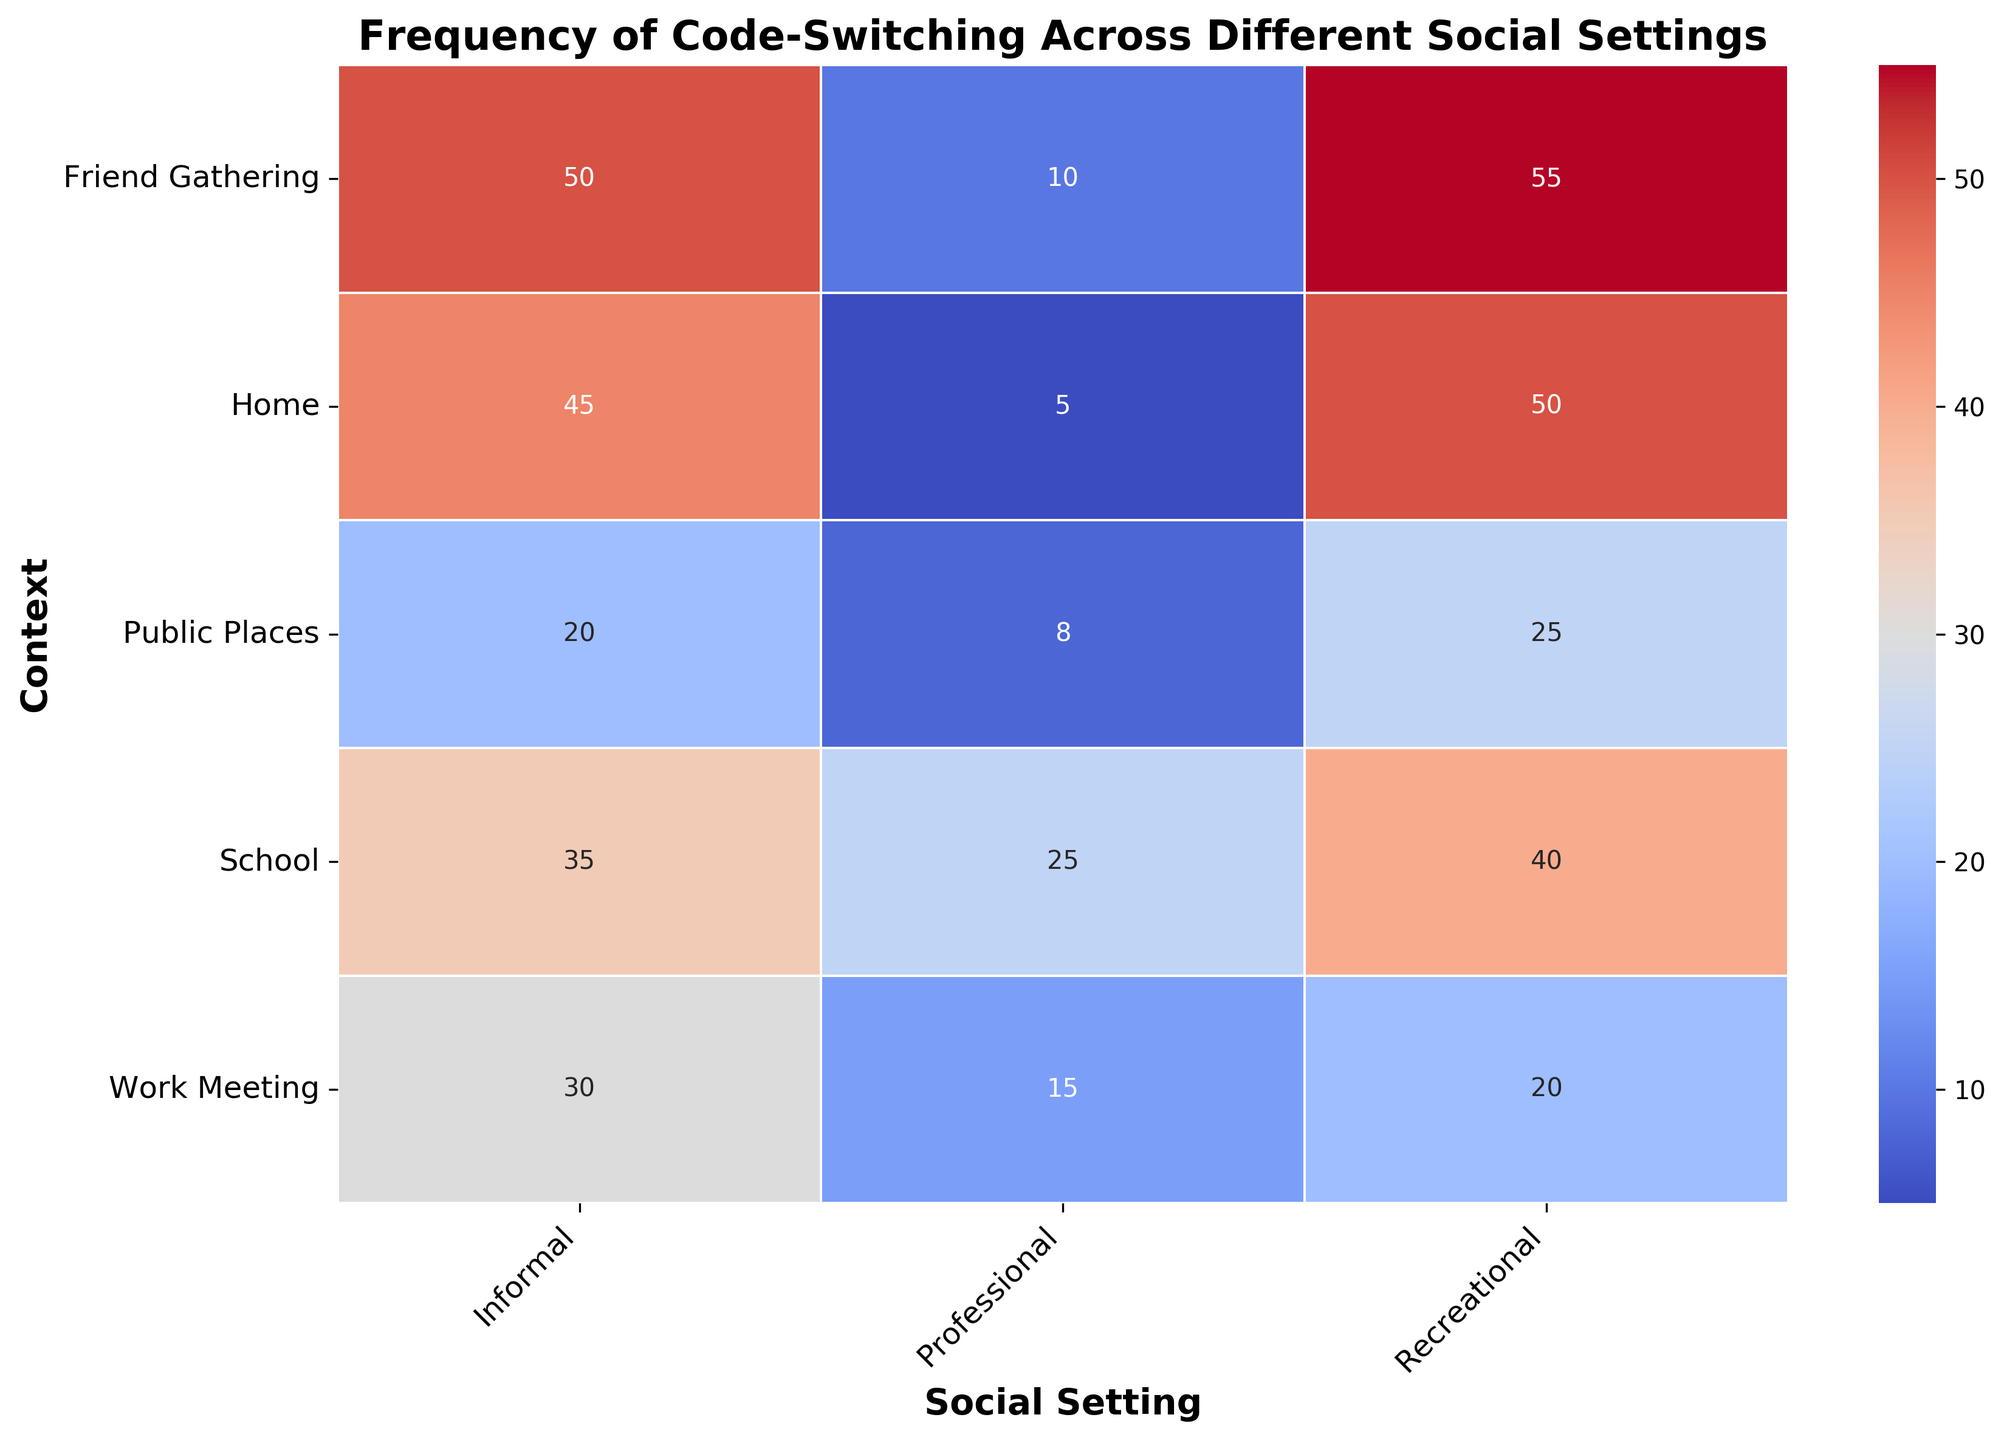What context has the highest frequency of code-switching in informal social settings? The figure shows different contexts and their frequency of code-switching across social settings. Looking at the 'Informal' column, the context with the highest frequency is 'Friend Gathering' with 50.
Answer: Friend Gathering Which social setting shows the lowest frequency of code-switching in the context 'Public Places'? Observing the 'Public Places' row, the lowest frequency in any social setting is 8 in the 'Professional' column.
Answer: Professional In which social setting and context is the frequency of code-switching exactly 25? The frequency of 25 appears in 'School' for 'Professional' and 'Public Places' for 'Recreational'. Both need to be mentioned as the question asked for both social setting and context.
Answer: School (Professional) and Public Places (Recreational) What is the difference in code-switching frequency between 'Informal' and 'Professional' social settings at 'Work Meeting'? For 'Work Meeting', 'Informal' has a frequency of 30, and 'Professional' has 15. The difference is 30 - 15 = 15.
Answer: 15 Which context has the most variation in code-switching frequency across all social settings, and what is the range? The context with the most variation can be seen by comparing the spread of frequencies. 'Friend Gathering' ranges from 10 to 55, yielding a range of 55 - 10 = 45, which is the highest among all contexts.
Answer: Friend Gathering, 45 What is the sum of code-switching frequencies for the 'Recreational' social setting across all contexts? The 'Recreational' frequencies are: Work Meeting (20), Home (50), School (40), Friend Gathering (55), and Public Places (25). Sum = 20 + 50 + 40 + 55 + 25 = 190.
Answer: 190 Which social setting shows the smallest variation in code-switching frequencies across contexts, and what is the range? Looking for the smallest spread of frequencies, 'Professional' social setting has values ranging from 5 to 25, so the range is 25 - 5 = 20.
Answer: Professional, 20 How does the frequency of code-switching in 'Home' compare between 'Professional' and 'Informal' social settings? For 'Home', the 'Professional' frequency is 5 and 'Informal' is 45. Thus, 'Informal' is higher by 45 - 5 = 40.
Answer: Informal is higher by 40 